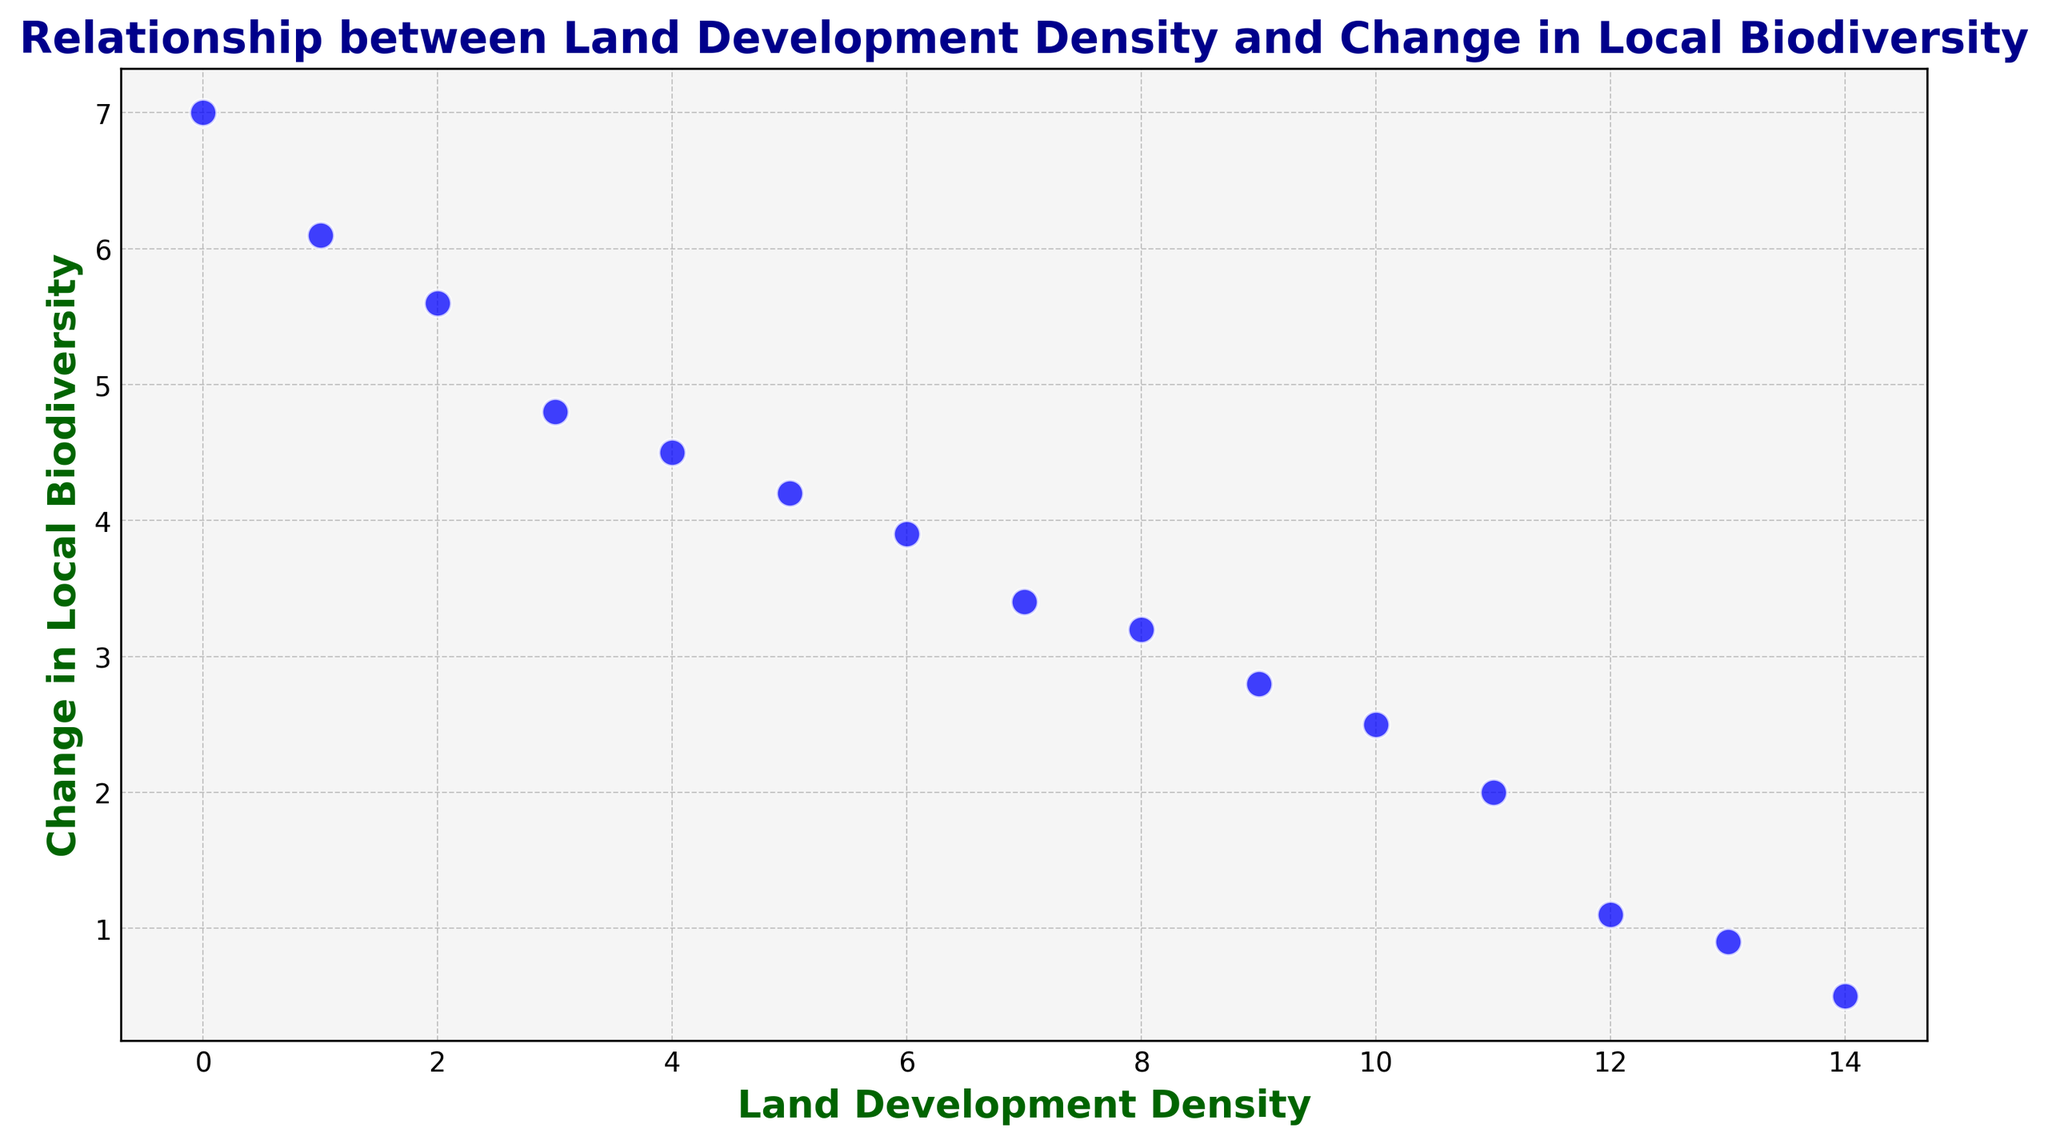How does a high land development density impact local biodiversity? By observing the scatter plot, a higher land development density correlates with a larger negative change in local biodiversity. For instance, data points with higher development density (e.g., densities 12, 13, 14) are associated with lower biodiversity values (1.1, 0.9, 0.5 respectively).
Answer: Negative impact What is the range of land development densities represented in the scatter plot? Reviewing the x-axis, the densities range from 0 to 14. The smallest and largest land development density values are clearly shown to be 0 and 14 respectively.
Answer: 0 to 14 What trend does the scatter plot show between land development density and change in local biodiversity? The scatter plot shows a downward trend, indicating a negative relationship between land development density and change in local biodiversity; meaning as land development density increases, the biodiversity tends to decrease.
Answer: Negative relationship Which data point represents the lowest change in local biodiversity, and what is the corresponding land development density? The lowest change in local biodiversity is around 0.5, which corresponds to a land development density of 14, as shown at the far end of the x-axis.
Answer: Density of 14 Are there any outliers or unusual points in the data, considering both axes? The data point with a land development density of 0 and a change in local biodiversity of 7.0 could be considered an outlier because it lies significantly far from the others in the positive direction, suggesting a minimal development with high biodiversity change.
Answer: Yes, at density 0 Which data points show the greatest improvement in local biodiversity, and what is their corresponding land development density? The greatest improvement in local biodiversity is shown by the point at density 0 with a change of 7.0, and the point at density 1 with a change of 6.1 on the y-axis, indicating minimal land development is associated with great improvements in biodiversity.
Answer: Density of 0 and 1 What is the average change in local biodiversity for land development densities less than or equal to 5? Perform calculations by taking the data points (2,5.6), (5,4.2), (3,4.8), (4,4.5), (1,6.1), and (0,7.0). The sum of values is 5.6 + 4.2 + 4.8 + 4.5 + 6.1 + 7.0 = 32.2. Therefore, the average is 32.2/6 = 5.37
Answer: 5.37 Between which range of land development densities does the steepest decline in local biodiversity occur? By examining the steepest sections in the scatter plot, the range between densities 12 and 14 shows a drastic decline in local biodiversity from about 1.1 to 0.9 to 0.5.
Answer: Density 12 to 14 How many data points represent a decrease in local biodiversity of more than 4 units? Looking at the y-axis, count the points where local biodiversity change is above 4 units. This is represented by points (densities 0, 1, 2, 3, 4, 5) with changes 7.0, 6.1, 5.6, 4.8, 4.5, 4.2 respectively.
Answer: 6 